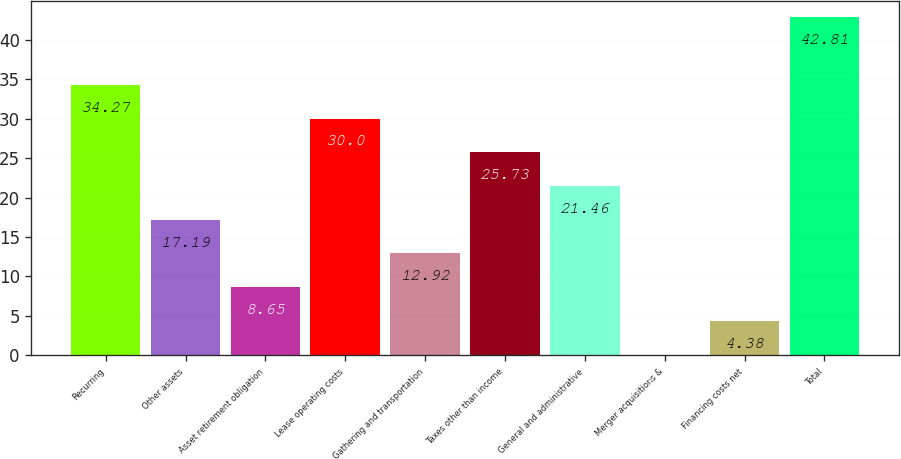<chart> <loc_0><loc_0><loc_500><loc_500><bar_chart><fcel>Recurring<fcel>Other assets<fcel>Asset retirement obligation<fcel>Lease operating costs<fcel>Gathering and transportation<fcel>Taxes other than income<fcel>General and administrative<fcel>Merger acquisitions &<fcel>Financing costs net<fcel>Total<nl><fcel>34.27<fcel>17.19<fcel>8.65<fcel>30<fcel>12.92<fcel>25.73<fcel>21.46<fcel>0.11<fcel>4.38<fcel>42.81<nl></chart> 